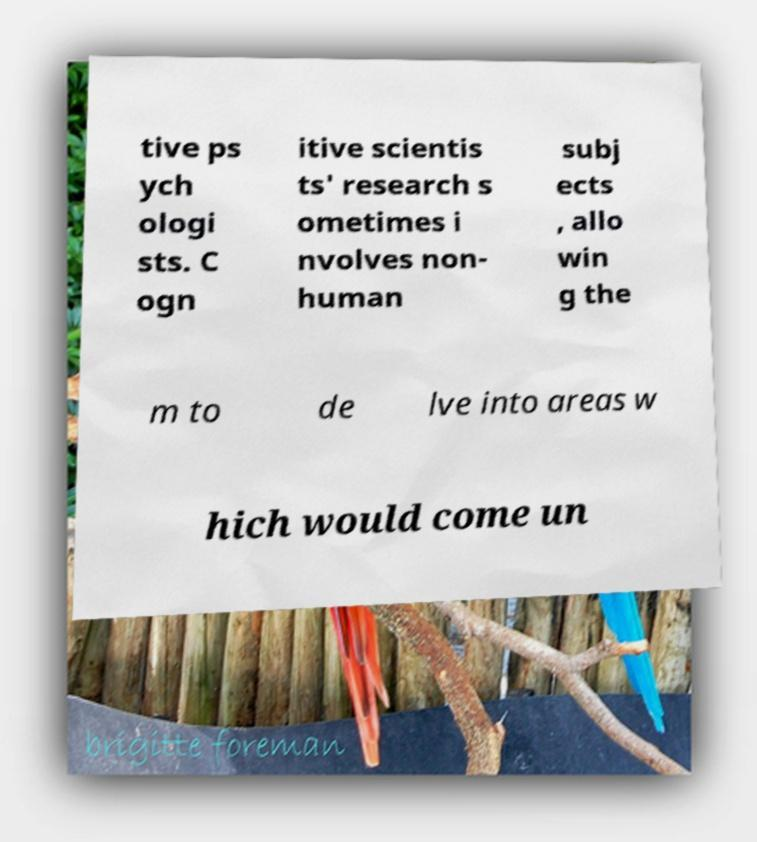Please read and relay the text visible in this image. What does it say? tive ps ych ologi sts. C ogn itive scientis ts' research s ometimes i nvolves non- human subj ects , allo win g the m to de lve into areas w hich would come un 